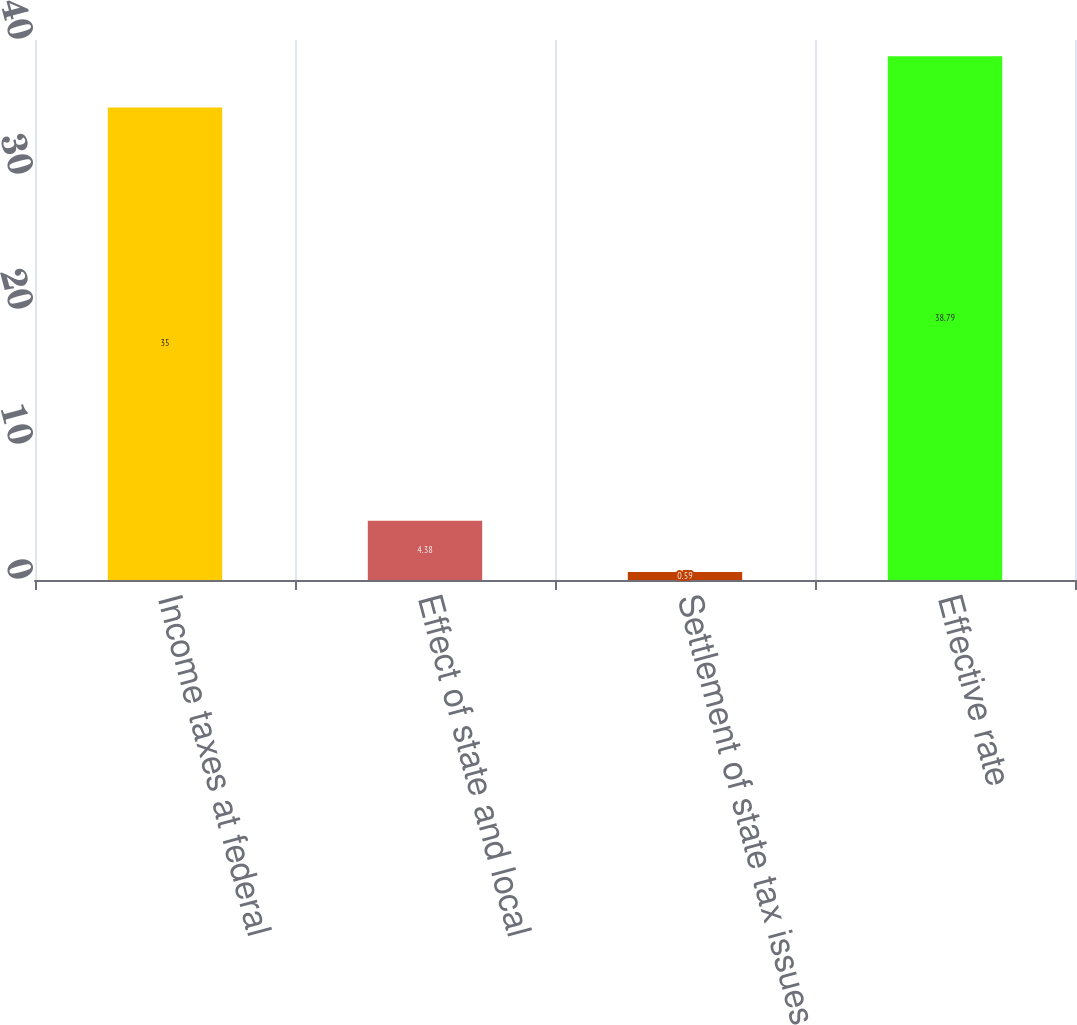Convert chart to OTSL. <chart><loc_0><loc_0><loc_500><loc_500><bar_chart><fcel>Income taxes at federal<fcel>Effect of state and local<fcel>Settlement of state tax issues<fcel>Effective rate<nl><fcel>35<fcel>4.38<fcel>0.59<fcel>38.79<nl></chart> 